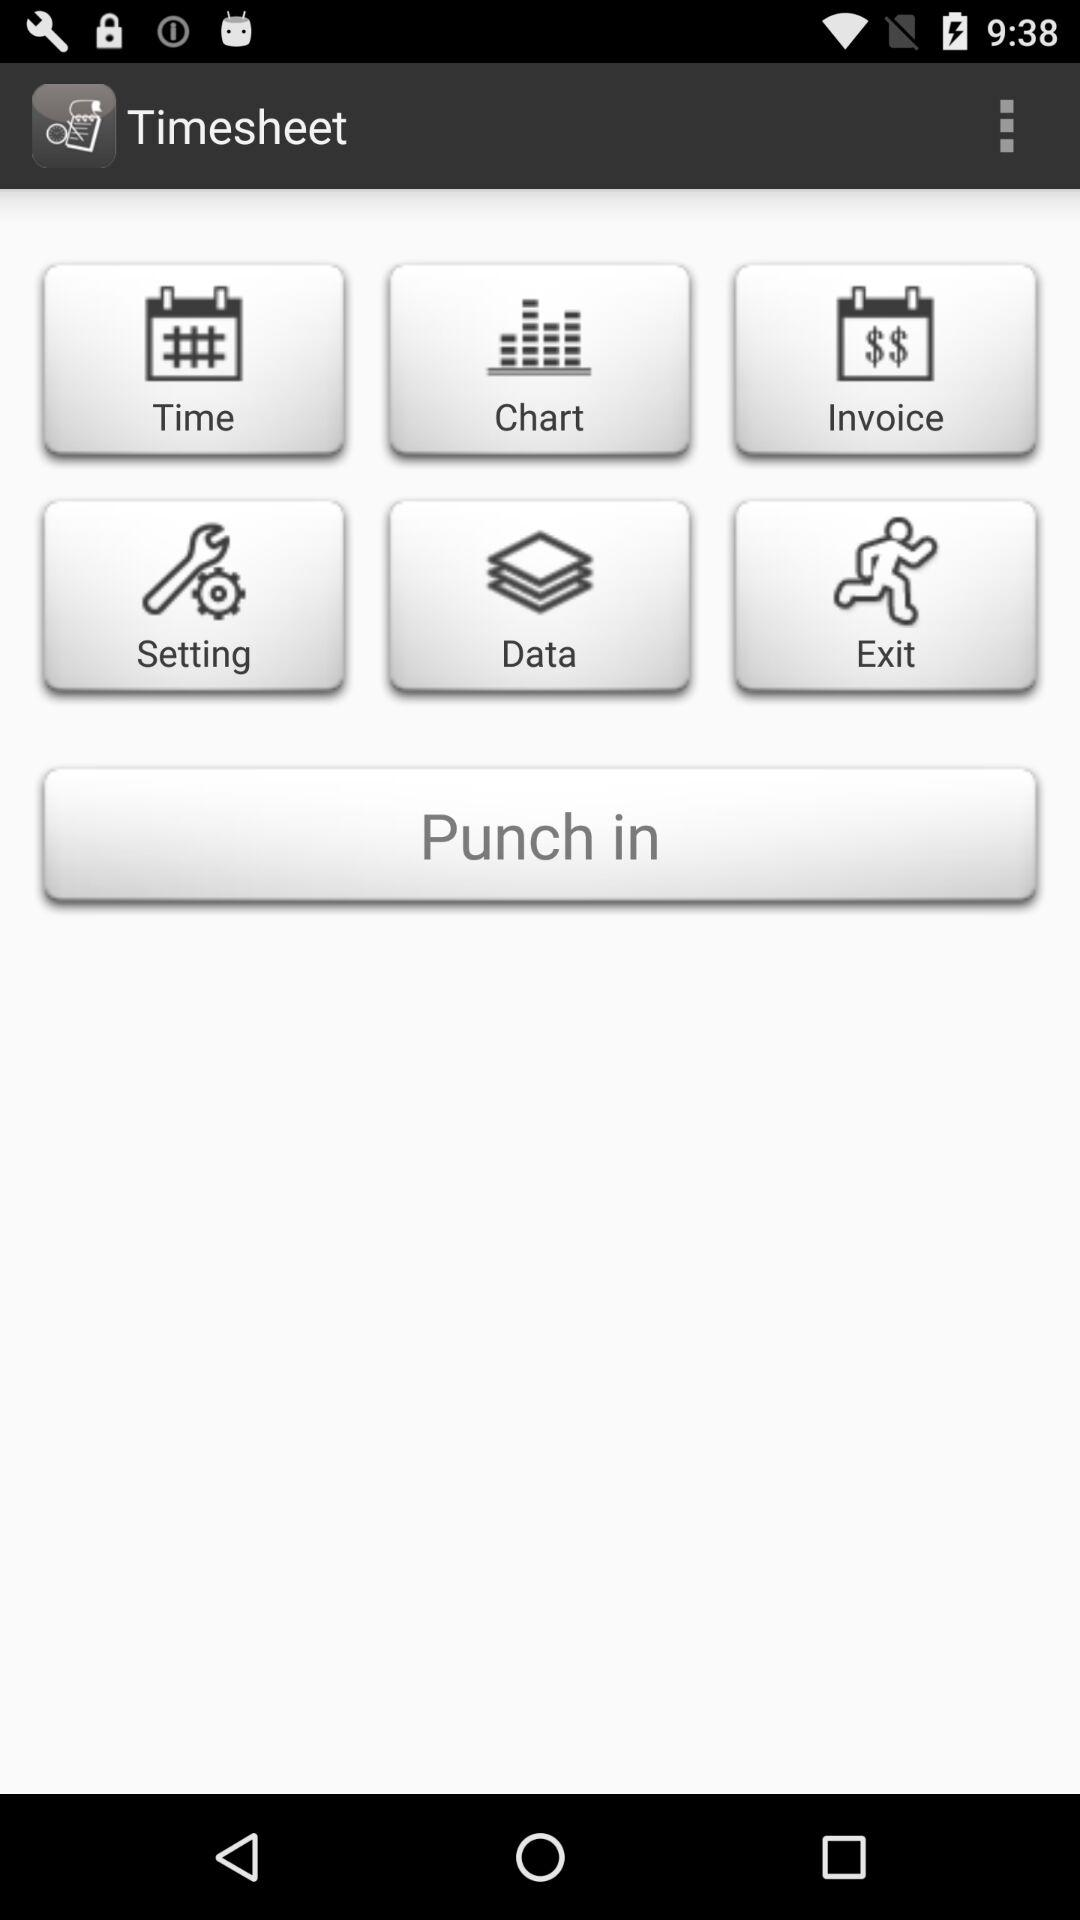What is the application name? The application name is "Timesheet". 